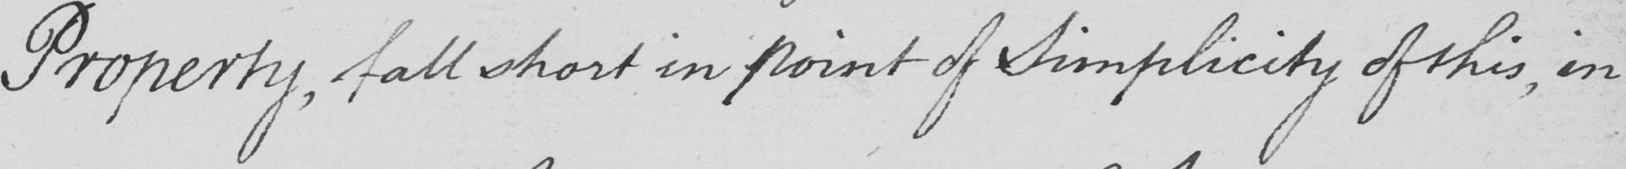What does this handwritten line say? Property , fall short in point of Simplicity of this , in 